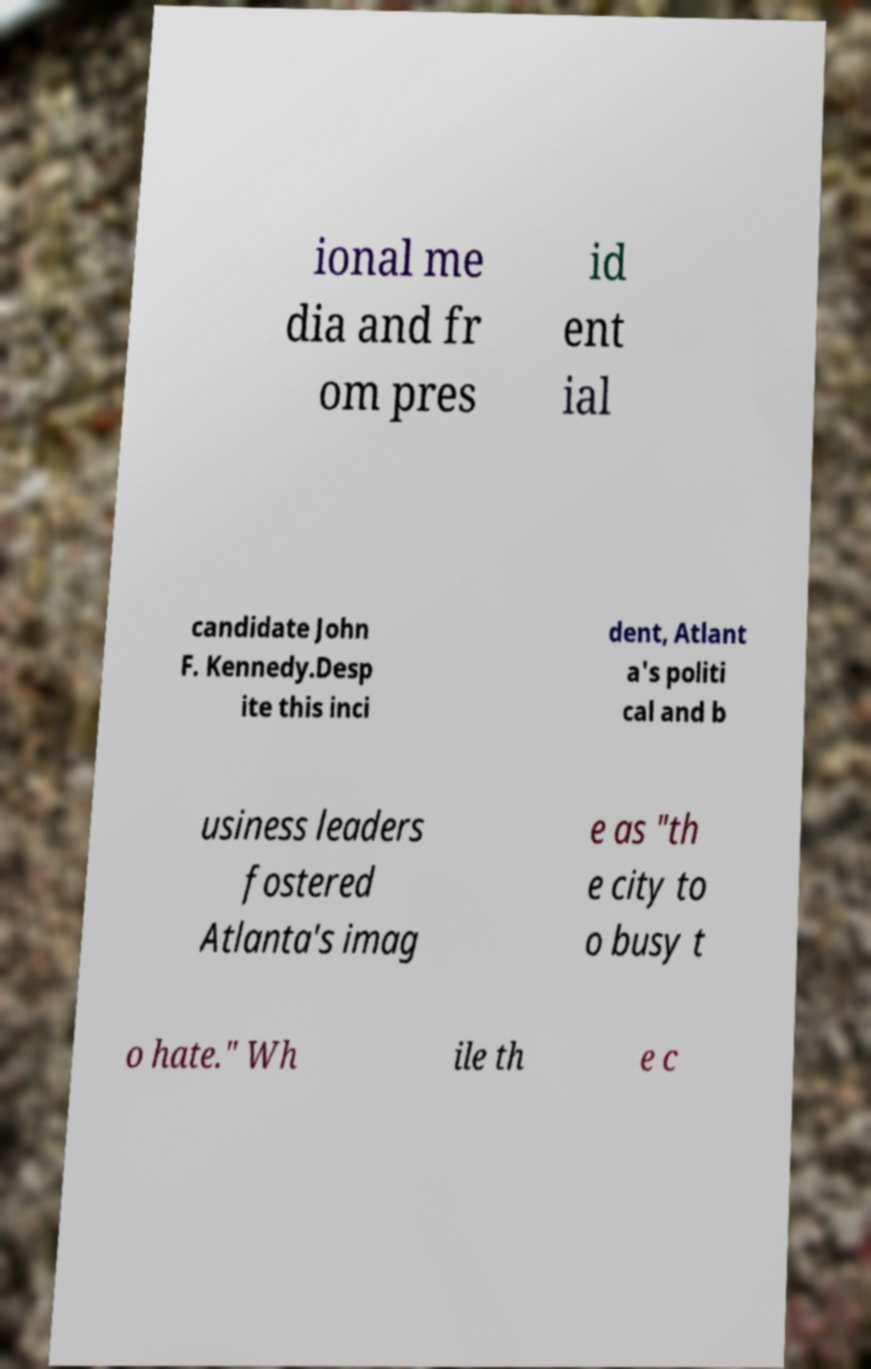Please identify and transcribe the text found in this image. ional me dia and fr om pres id ent ial candidate John F. Kennedy.Desp ite this inci dent, Atlant a's politi cal and b usiness leaders fostered Atlanta's imag e as "th e city to o busy t o hate." Wh ile th e c 